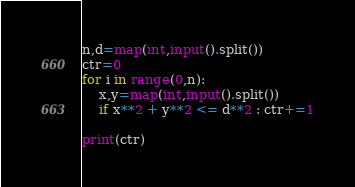Convert code to text. <code><loc_0><loc_0><loc_500><loc_500><_Python_>n,d=map(int,input().split())
ctr=0
for i in range(0,n):
    x,y=map(int,input().split())
    if x**2 + y**2 <= d**2 : ctr+=1

print(ctr)</code> 